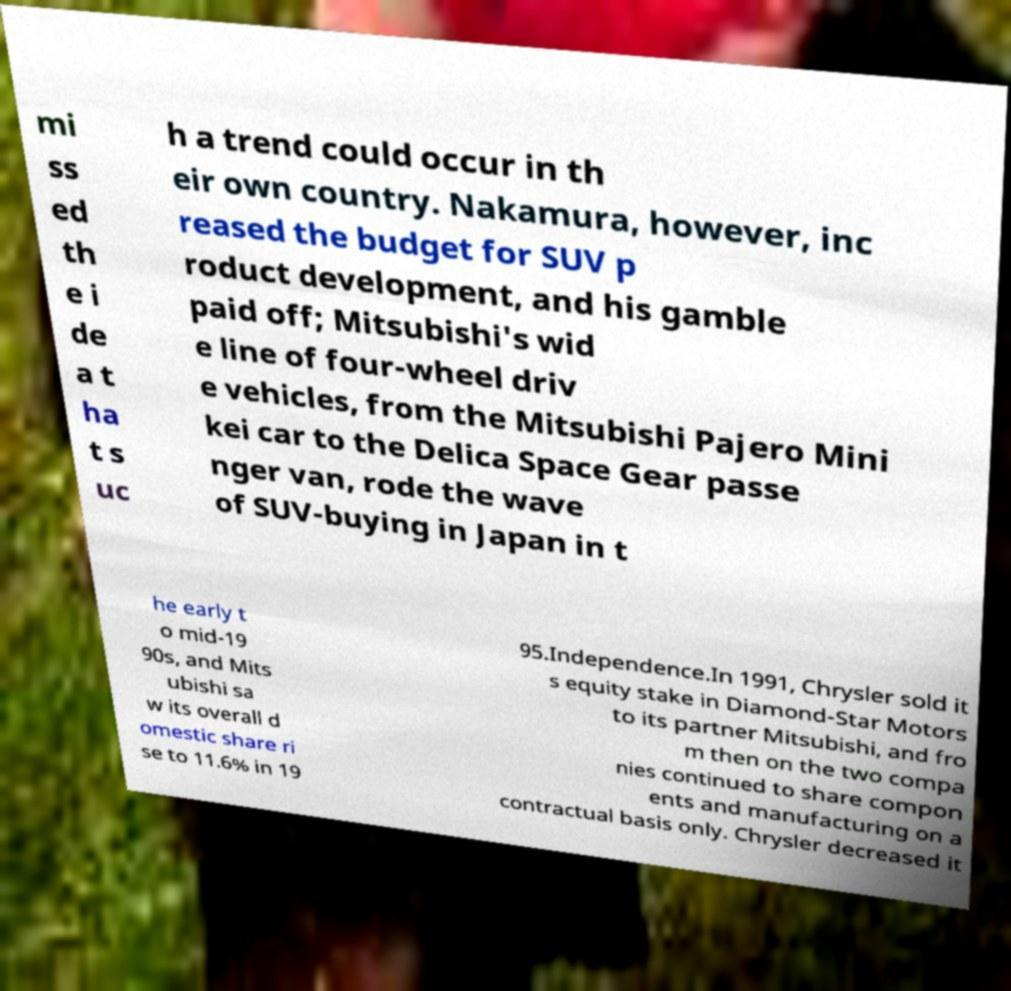Could you extract and type out the text from this image? mi ss ed th e i de a t ha t s uc h a trend could occur in th eir own country. Nakamura, however, inc reased the budget for SUV p roduct development, and his gamble paid off; Mitsubishi's wid e line of four-wheel driv e vehicles, from the Mitsubishi Pajero Mini kei car to the Delica Space Gear passe nger van, rode the wave of SUV-buying in Japan in t he early t o mid-19 90s, and Mits ubishi sa w its overall d omestic share ri se to 11.6% in 19 95.Independence.In 1991, Chrysler sold it s equity stake in Diamond-Star Motors to its partner Mitsubishi, and fro m then on the two compa nies continued to share compon ents and manufacturing on a contractual basis only. Chrysler decreased it 